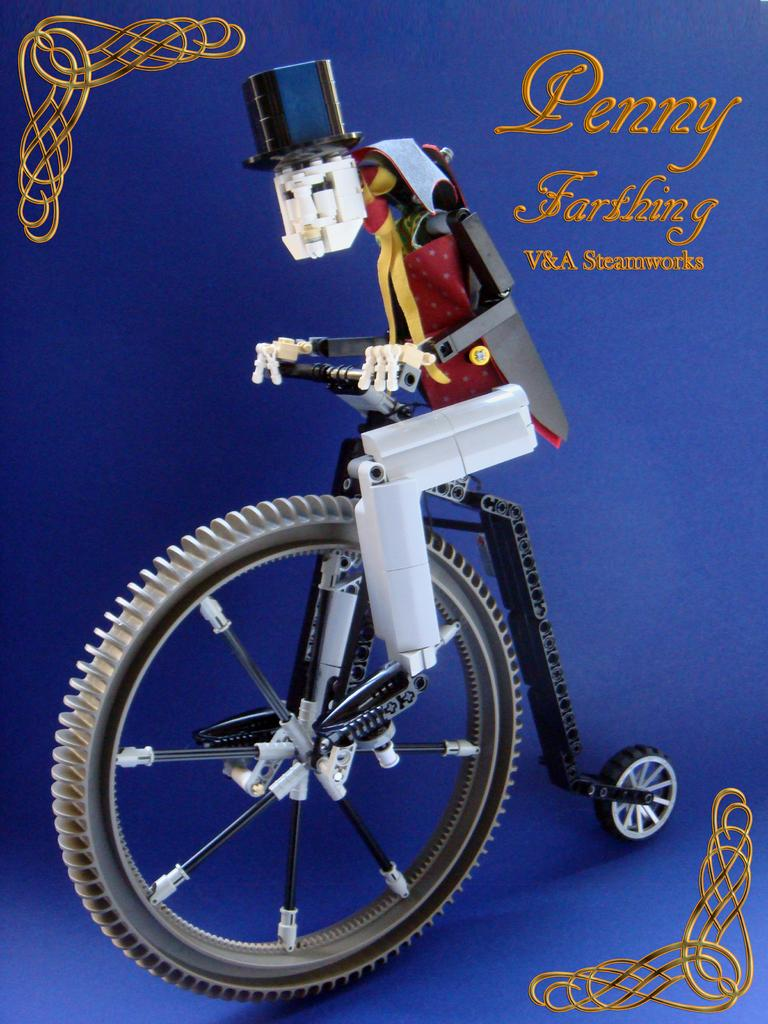What color is the poster in the image? The poster is blue in color. What can be seen on the poster besides its color? There is a design and text on the poster. What type of object is depicted on the poster? There is a toy depicted on the poster. What level of difficulty is indicated by the insect in the alley on the poster? There is no insect or alley present on the poster; it only features a blue color, a design, text, and a toy. 